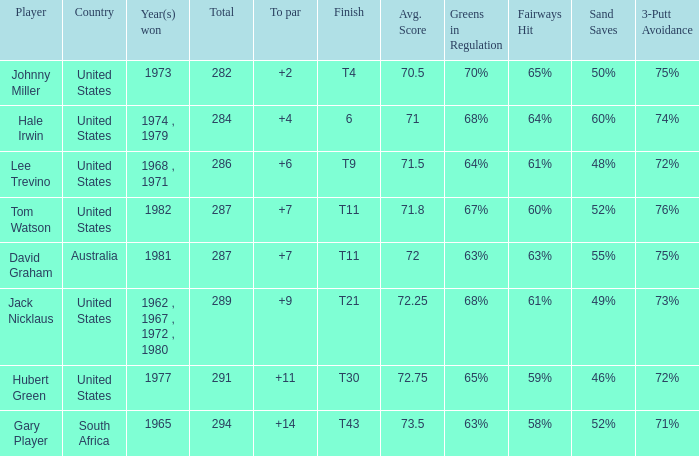WHAT IS THE TO PAR WITH A FINISH OF T11, FOR DAVID GRAHAM? 7.0. 